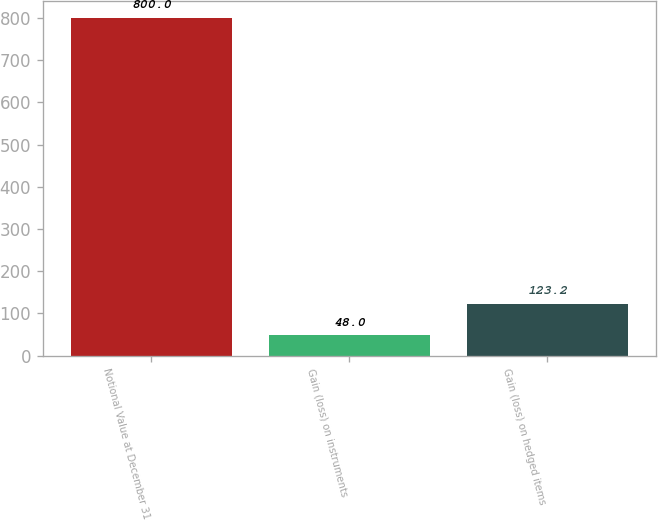<chart> <loc_0><loc_0><loc_500><loc_500><bar_chart><fcel>Notional Value at December 31<fcel>Gain (loss) on instruments<fcel>Gain (loss) on hedged items<nl><fcel>800<fcel>48<fcel>123.2<nl></chart> 